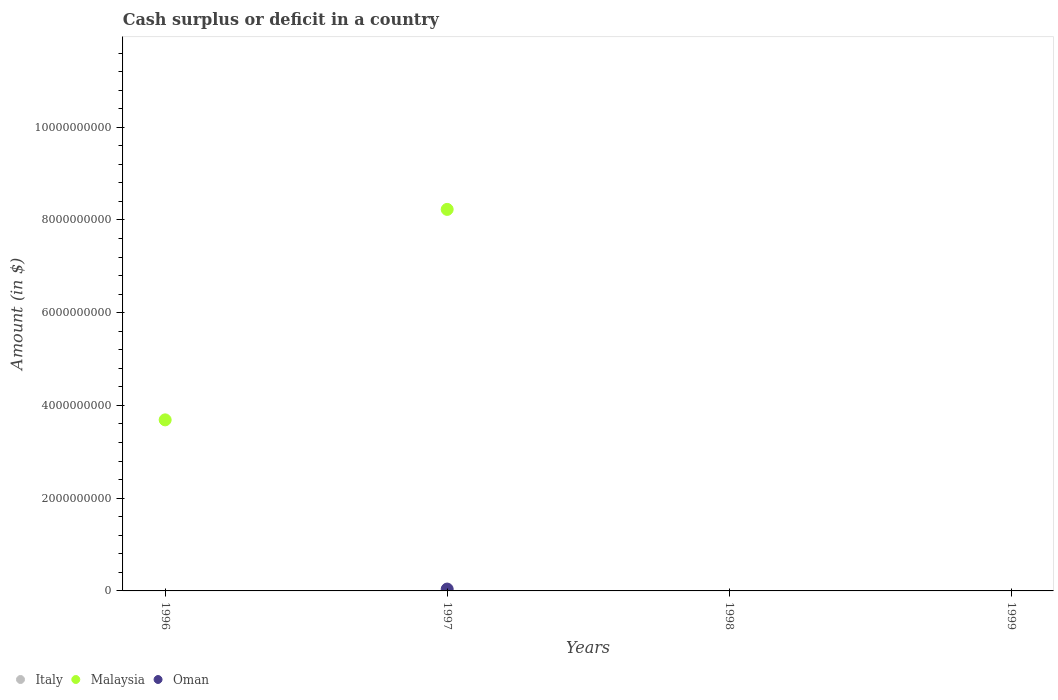What is the amount of cash surplus or deficit in Malaysia in 1996?
Make the answer very short. 3.69e+09. Across all years, what is the maximum amount of cash surplus or deficit in Malaysia?
Your answer should be compact. 8.23e+09. Across all years, what is the minimum amount of cash surplus or deficit in Italy?
Your answer should be very brief. 0. In which year was the amount of cash surplus or deficit in Oman maximum?
Ensure brevity in your answer.  1997. What is the total amount of cash surplus or deficit in Malaysia in the graph?
Keep it short and to the point. 1.19e+1. What is the difference between the amount of cash surplus or deficit in Malaysia in 1996 and that in 1997?
Provide a short and direct response. -4.54e+09. What is the difference between the amount of cash surplus or deficit in Oman in 1998 and the amount of cash surplus or deficit in Italy in 1997?
Provide a succinct answer. 0. What is the average amount of cash surplus or deficit in Oman per year?
Your response must be concise. 1.00e+07. In the year 1997, what is the difference between the amount of cash surplus or deficit in Malaysia and amount of cash surplus or deficit in Oman?
Give a very brief answer. 8.19e+09. In how many years, is the amount of cash surplus or deficit in Oman greater than 3200000000 $?
Your answer should be very brief. 0. What is the difference between the highest and the lowest amount of cash surplus or deficit in Malaysia?
Your answer should be very brief. 8.23e+09. In how many years, is the amount of cash surplus or deficit in Malaysia greater than the average amount of cash surplus or deficit in Malaysia taken over all years?
Provide a short and direct response. 2. Is it the case that in every year, the sum of the amount of cash surplus or deficit in Oman and amount of cash surplus or deficit in Malaysia  is greater than the amount of cash surplus or deficit in Italy?
Ensure brevity in your answer.  No. Does the amount of cash surplus or deficit in Malaysia monotonically increase over the years?
Your response must be concise. No. Is the amount of cash surplus or deficit in Italy strictly less than the amount of cash surplus or deficit in Malaysia over the years?
Your response must be concise. Yes. What is the difference between two consecutive major ticks on the Y-axis?
Give a very brief answer. 2.00e+09. Does the graph contain grids?
Your answer should be very brief. No. Where does the legend appear in the graph?
Keep it short and to the point. Bottom left. How are the legend labels stacked?
Ensure brevity in your answer.  Horizontal. What is the title of the graph?
Your answer should be very brief. Cash surplus or deficit in a country. What is the label or title of the X-axis?
Make the answer very short. Years. What is the label or title of the Y-axis?
Ensure brevity in your answer.  Amount (in $). What is the Amount (in $) in Malaysia in 1996?
Provide a short and direct response. 3.69e+09. What is the Amount (in $) of Oman in 1996?
Keep it short and to the point. 0. What is the Amount (in $) of Italy in 1997?
Keep it short and to the point. 0. What is the Amount (in $) in Malaysia in 1997?
Give a very brief answer. 8.23e+09. What is the Amount (in $) of Oman in 1997?
Give a very brief answer. 4.01e+07. What is the Amount (in $) of Italy in 1998?
Make the answer very short. 0. What is the Amount (in $) of Malaysia in 1998?
Your response must be concise. 0. What is the Amount (in $) of Italy in 1999?
Ensure brevity in your answer.  0. What is the Amount (in $) in Oman in 1999?
Your answer should be compact. 0. Across all years, what is the maximum Amount (in $) of Malaysia?
Offer a terse response. 8.23e+09. Across all years, what is the maximum Amount (in $) in Oman?
Keep it short and to the point. 4.01e+07. Across all years, what is the minimum Amount (in $) of Malaysia?
Ensure brevity in your answer.  0. Across all years, what is the minimum Amount (in $) in Oman?
Your response must be concise. 0. What is the total Amount (in $) in Italy in the graph?
Provide a succinct answer. 0. What is the total Amount (in $) in Malaysia in the graph?
Your answer should be compact. 1.19e+1. What is the total Amount (in $) of Oman in the graph?
Keep it short and to the point. 4.01e+07. What is the difference between the Amount (in $) in Malaysia in 1996 and that in 1997?
Make the answer very short. -4.54e+09. What is the difference between the Amount (in $) of Malaysia in 1996 and the Amount (in $) of Oman in 1997?
Provide a succinct answer. 3.65e+09. What is the average Amount (in $) in Malaysia per year?
Your response must be concise. 2.98e+09. What is the average Amount (in $) in Oman per year?
Offer a very short reply. 1.00e+07. In the year 1997, what is the difference between the Amount (in $) in Malaysia and Amount (in $) in Oman?
Give a very brief answer. 8.19e+09. What is the ratio of the Amount (in $) in Malaysia in 1996 to that in 1997?
Make the answer very short. 0.45. What is the difference between the highest and the lowest Amount (in $) of Malaysia?
Provide a succinct answer. 8.23e+09. What is the difference between the highest and the lowest Amount (in $) in Oman?
Your response must be concise. 4.01e+07. 